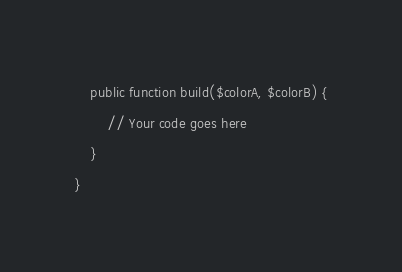<code> <loc_0><loc_0><loc_500><loc_500><_PHP_>
    public function build($colorA, $colorB) {
        // Your code goes here
    }
}


</code> 